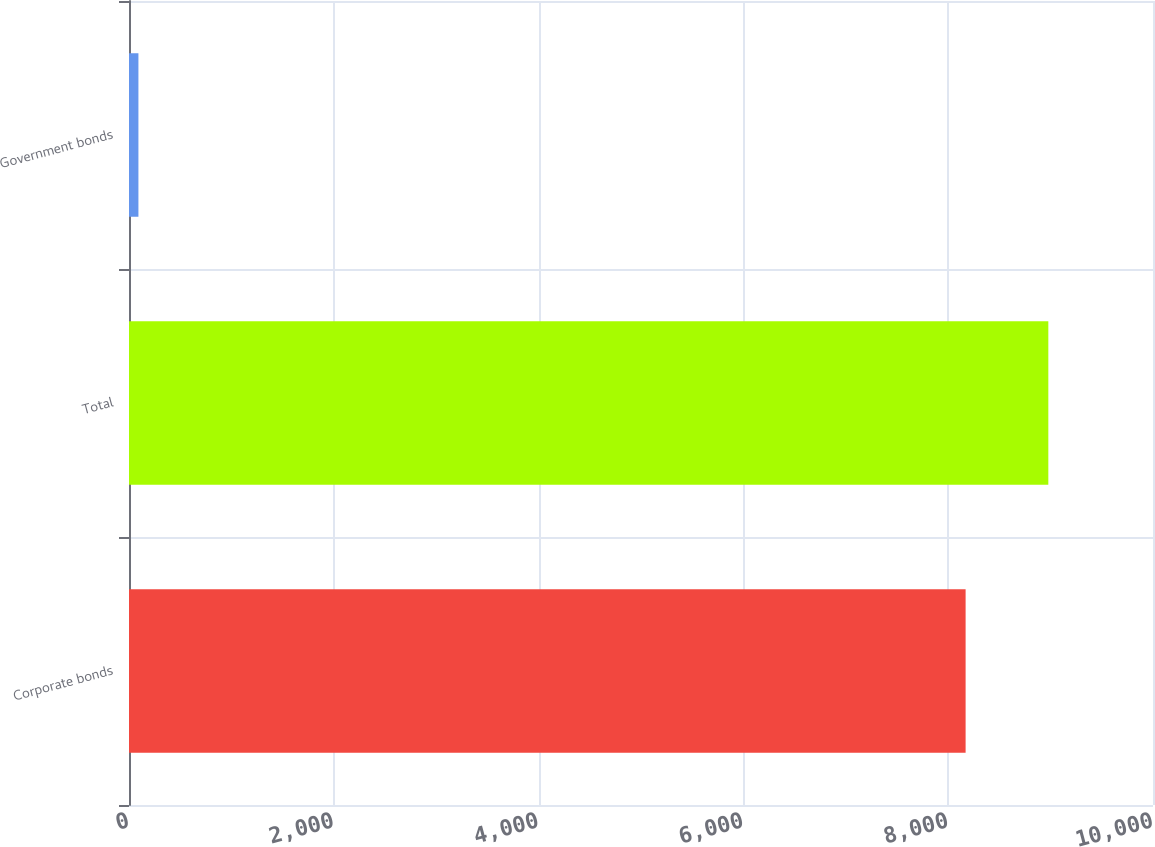Convert chart to OTSL. <chart><loc_0><loc_0><loc_500><loc_500><bar_chart><fcel>Corporate bonds<fcel>Total<fcel>Government bonds<nl><fcel>8170<fcel>8977.8<fcel>92<nl></chart> 